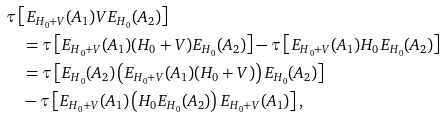<formula> <loc_0><loc_0><loc_500><loc_500>& \tau \left [ E _ { H _ { 0 } + V } ( A _ { 1 } ) V E _ { H _ { 0 } } ( A _ { 2 } ) \right ] \\ & \quad = \tau \left [ E _ { H _ { 0 } + V } ( A _ { 1 } ) ( H _ { 0 } + V ) E _ { H _ { 0 } } ( A _ { 2 } ) \right ] - \tau \left [ E _ { H _ { 0 } + V } ( A _ { 1 } ) H _ { 0 } E _ { H _ { 0 } } ( A _ { 2 } ) \right ] \\ & \quad = \tau \left [ E _ { H _ { 0 } } ( A _ { 2 } ) \left ( E _ { H _ { 0 } + V } ( A _ { 1 } ) ( H _ { 0 } + V ) \right ) E _ { H _ { 0 } } ( A _ { 2 } ) \right ] \\ & \quad - \tau \left [ E _ { H _ { 0 } + V } ( A _ { 1 } ) \left ( H _ { 0 } E _ { H _ { 0 } } ( A _ { 2 } ) \right ) E _ { H _ { 0 } + V } ( A _ { 1 } ) \right ] ,</formula> 